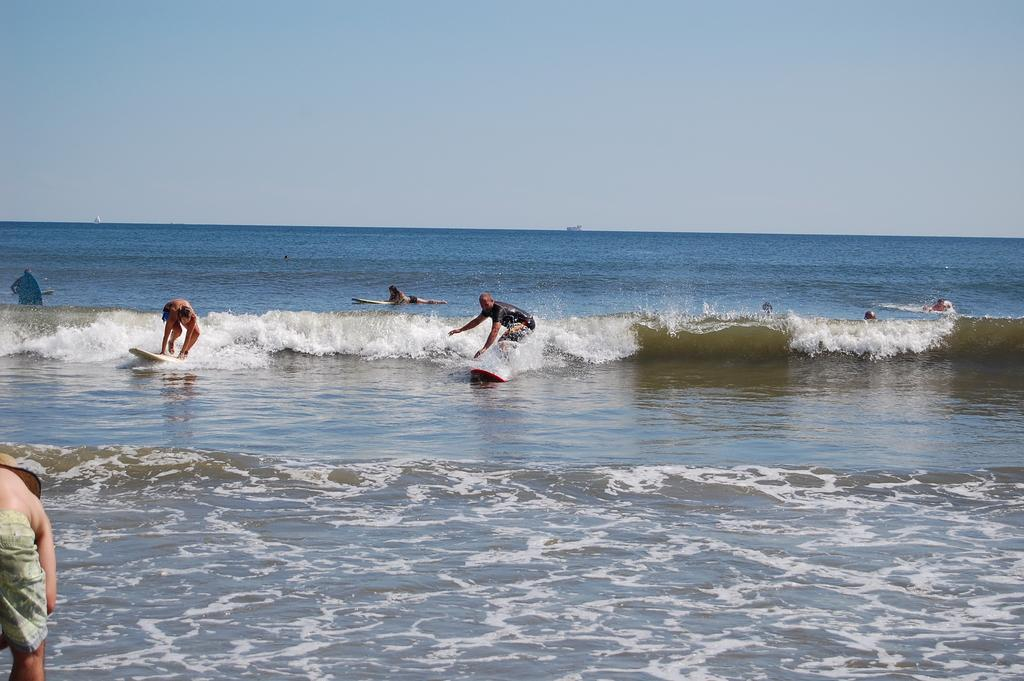What are the people in the image doing? There is a group of people in the water. What are some people using in the water? Some people have surfboards. What color is the water in the image? The water is blue. What can be seen above the water in the image? There is a sky visible in the image. What type of meat can be seen hanging from the surfboards in the image? There is no meat present in the image, and surfboards are not used for hanging meat. 